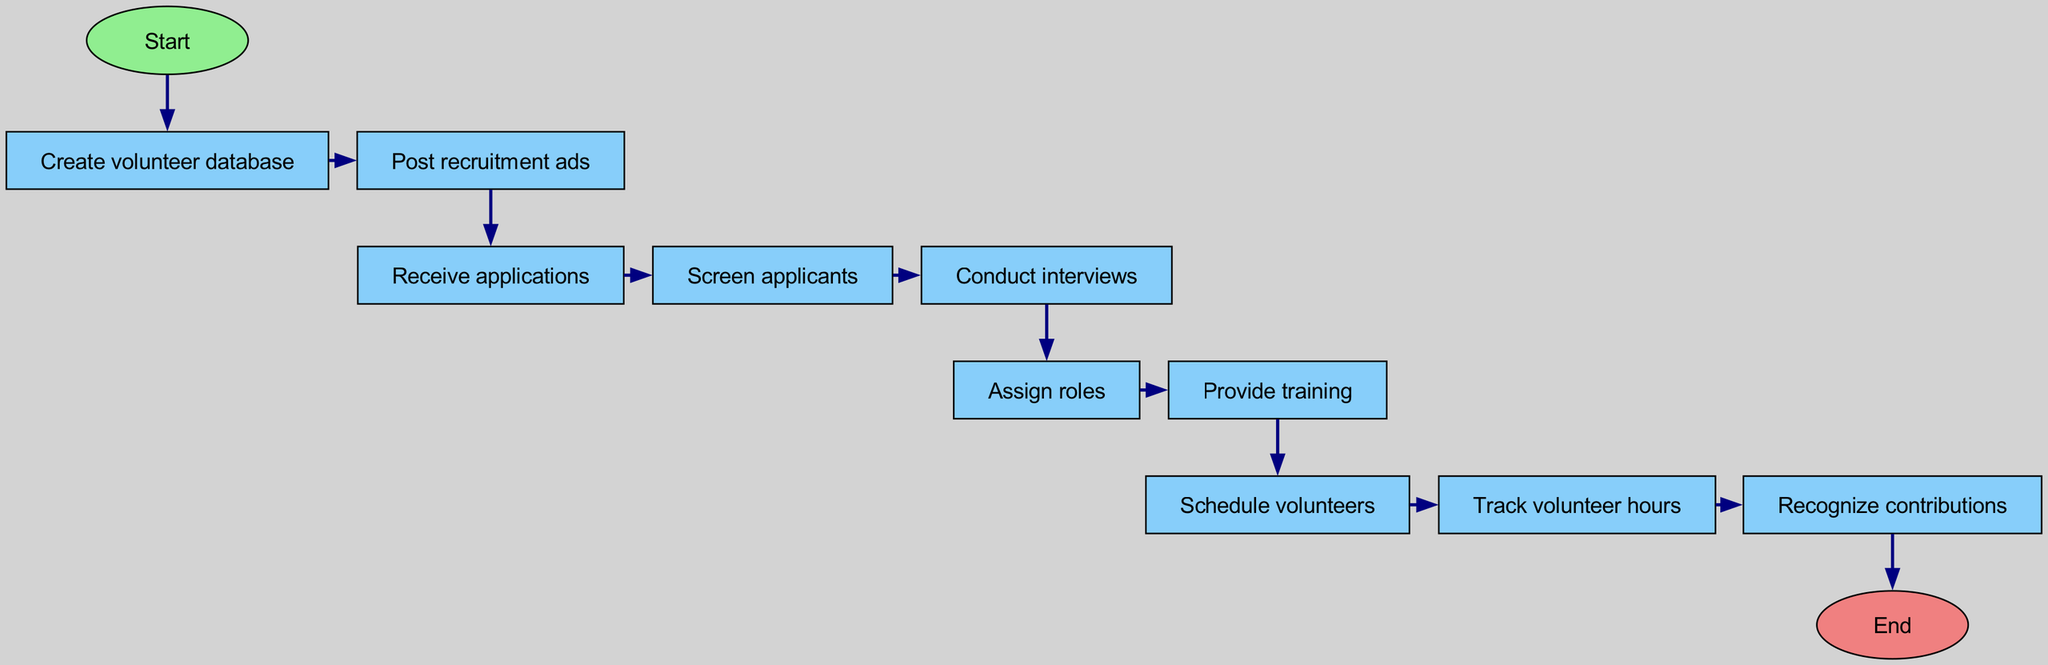What is the first step in the diagram? The first node labeled "Start" indicates that the diagram begins here, representing the initiation of the volunteer recruitment and management system.
Answer: Start How many nodes are in the diagram? By counting all the nodes listed in the data, there are a total of twelve nodes from the "Start" to "End".
Answer: Twelve What does the node "Conduct interviews" lead to? The node "Conduct interviews" (node 6) has a direct connection that points to the "Assign roles" node (node 7), indicating the next step after conducting interviews.
Answer: Assign roles Which task happens right before "Provide training"? The task before "Provide training" is "Assign roles," which is a necessary step to determine what roles the volunteers will take before they receive training.
Answer: Assign roles Is "Track volunteer hours" connected directly to "Post recruitment ads"? Upon examining the edges in the diagram, "Track volunteer hours" (node 10) is not directly connected to "Post recruitment ads" (node 3), as they are separated by several other nodes in the flow.
Answer: No What are the three nodes grouped together after "Receive applications"? After "Receive applications," the nodes that follow in sequence are "Screen applicants," "Conduct interviews," and "Assign roles." This grouping indicates a series of assessments and assignments.
Answer: Screen applicants, Conduct interviews, Assign roles How many edges connect the nodes in the diagram? The edges represent the connections between the nodes, and by counting the listed edges, there are eleven directed edges in total that guide the flow from start to finish.
Answer: Eleven What is the purpose of the node "Recognize contributions"? The node "Recognize contributions" signifies the need to acknowledge and appreciate the efforts of the volunteers, highlighting the importance of recognition in volunteer management.
Answer: To acknowledge efforts Which nodes are marked as oval-shaped? The nodes "Start" and "End" are uniquely shaped as ovals, indicating they serve as the entry and exit points of the flowchart, which are different from other rectangular nodes.
Answer: Start, End What step follows "Schedule volunteers"? The node that follows "Schedule volunteers" is "Track volunteer hours," indicating that after scheduling, there is a need to monitor the time volunteers spend on their roles and responsibilities.
Answer: Track volunteer hours 